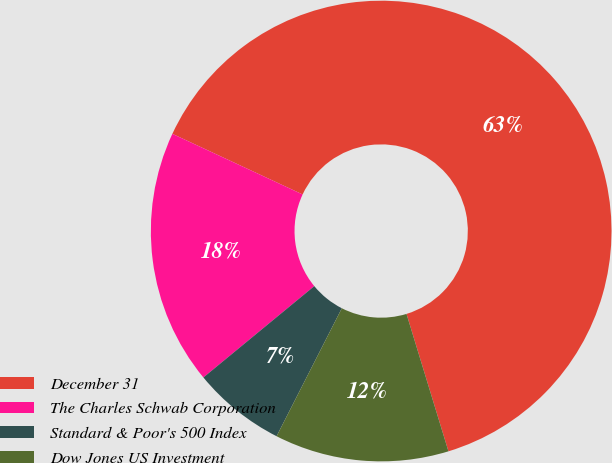Convert chart. <chart><loc_0><loc_0><loc_500><loc_500><pie_chart><fcel>December 31<fcel>The Charles Schwab Corporation<fcel>Standard & Poor's 500 Index<fcel>Dow Jones US Investment<nl><fcel>63.35%<fcel>17.9%<fcel>6.53%<fcel>12.22%<nl></chart> 